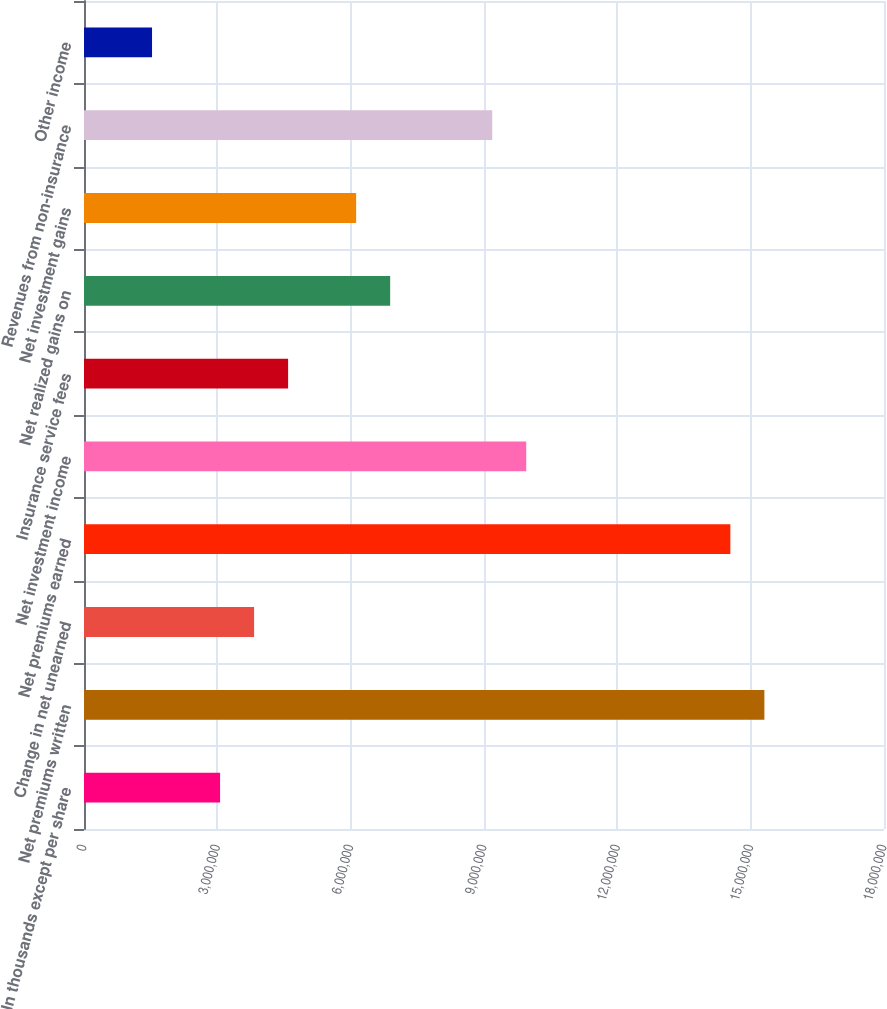Convert chart. <chart><loc_0><loc_0><loc_500><loc_500><bar_chart><fcel>(In thousands except per share<fcel>Net premiums written<fcel>Change in net unearned<fcel>Net premiums earned<fcel>Net investment income<fcel>Insurance service fees<fcel>Net realized gains on<fcel>Net investment gains<fcel>Revenues from non-insurance<fcel>Other income<nl><fcel>3.06168e+06<fcel>1.53084e+07<fcel>3.82709e+06<fcel>1.45429e+07<fcel>9.95044e+06<fcel>4.59251e+06<fcel>6.88877e+06<fcel>6.12335e+06<fcel>9.18502e+06<fcel>1.53084e+06<nl></chart> 